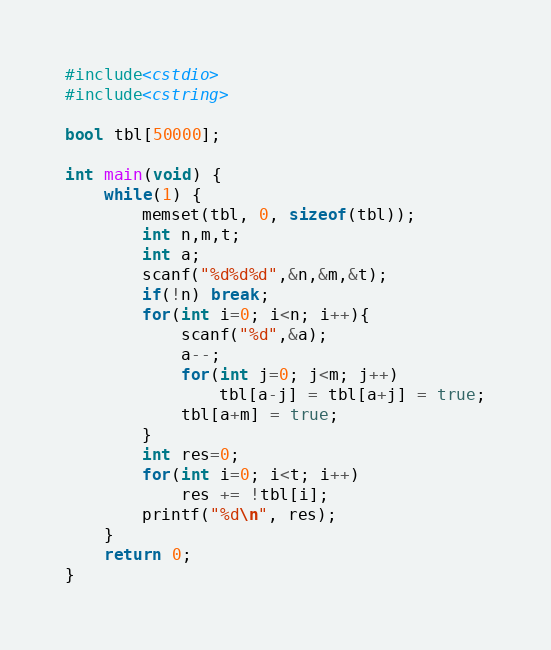<code> <loc_0><loc_0><loc_500><loc_500><_C++_>#include<cstdio>
#include<cstring>

bool tbl[50000];

int main(void) {
    while(1) {
        memset(tbl, 0, sizeof(tbl));
        int n,m,t;
        int a;
        scanf("%d%d%d",&n,&m,&t);
        if(!n) break;
        for(int i=0; i<n; i++){
            scanf("%d",&a);
            a--;
            for(int j=0; j<m; j++)
                tbl[a-j] = tbl[a+j] = true;
            tbl[a+m] = true;
        }
        int res=0;
        for(int i=0; i<t; i++)
            res += !tbl[i];
        printf("%d\n", res);
    }
    return 0;
}</code> 